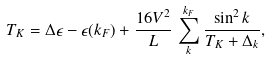Convert formula to latex. <formula><loc_0><loc_0><loc_500><loc_500>T _ { K } = \Delta \epsilon - \epsilon ( k _ { F } ) + \frac { 1 6 V ^ { 2 } } { L } \, \sum _ { k } ^ { k _ { F } } \frac { \sin ^ { 2 } k } { T _ { K } + \Delta _ { k } } ,</formula> 